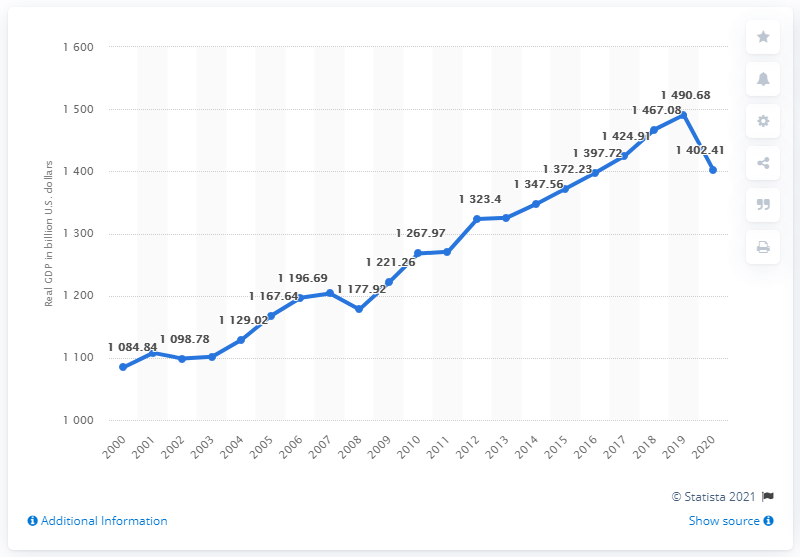Give some essential details in this illustration. In the year 2020, the real gross domestic product of New York was 1402.41. What was New York's Gross Domestic Product (GDP) in the previous year? In 1490.68.. 